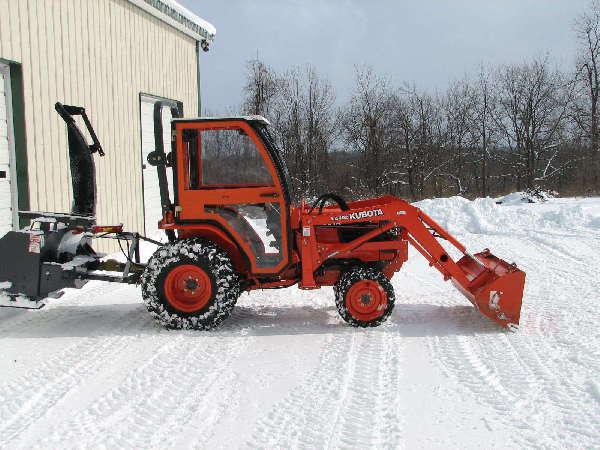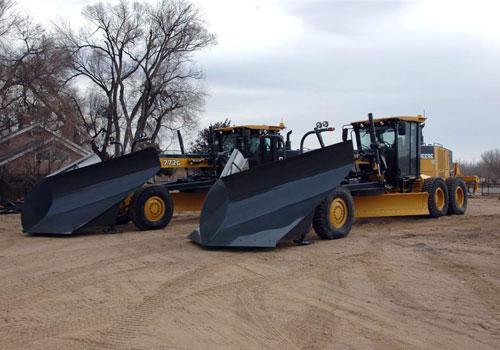The first image is the image on the left, the second image is the image on the right. For the images displayed, is the sentence "There is snow in the image on the left." factually correct? Answer yes or no. Yes. The first image is the image on the left, the second image is the image on the right. Evaluate the accuracy of this statement regarding the images: "There is a snowplow on a snow-covered surface.". Is it true? Answer yes or no. Yes. 